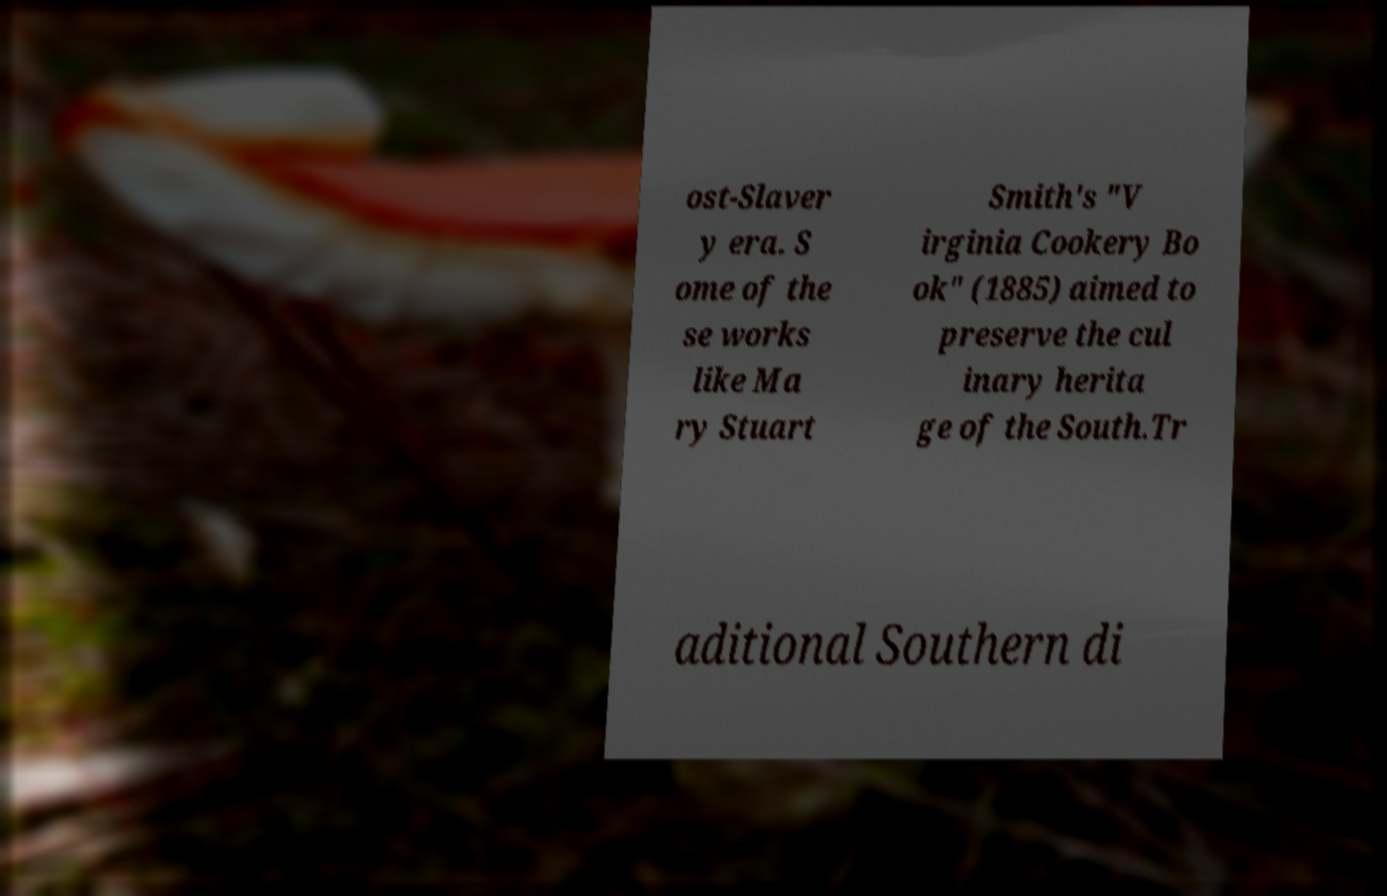Can you accurately transcribe the text from the provided image for me? ost-Slaver y era. S ome of the se works like Ma ry Stuart Smith's "V irginia Cookery Bo ok" (1885) aimed to preserve the cul inary herita ge of the South.Tr aditional Southern di 